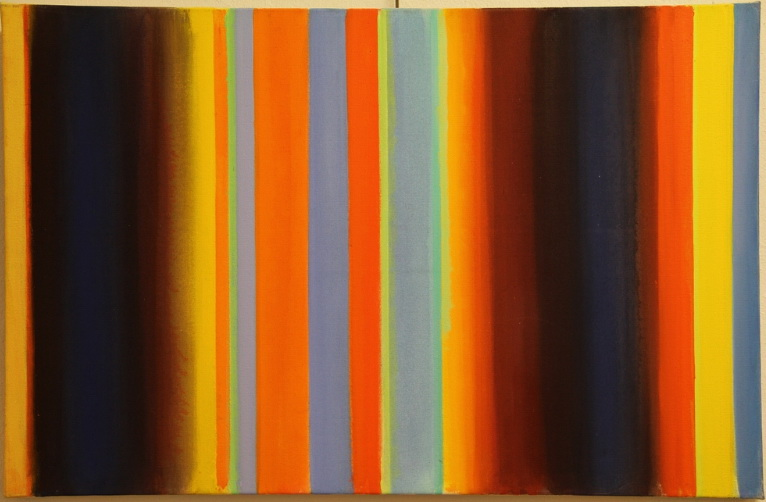Write a detailed description of the given image. The image showcases an abstract painting characterized by its vibrant and cleanly separated vertical stripes. The colors range from deep blue and black to bright orange, yellow, and various shades of blue and gray. Each stripe varies not only in color but in width as well, creating a dynamic rhythm across the canvas. This piece is reminiscent of the color field painting style, which focuses on large expanses of color and an emotional effect rooted in simplicity. This painting not only echoes the historical essence of abstract expressionism from the mid-20th century but also evokes a modern sense of tranquility and order through its symmetrical yet bold approach. 